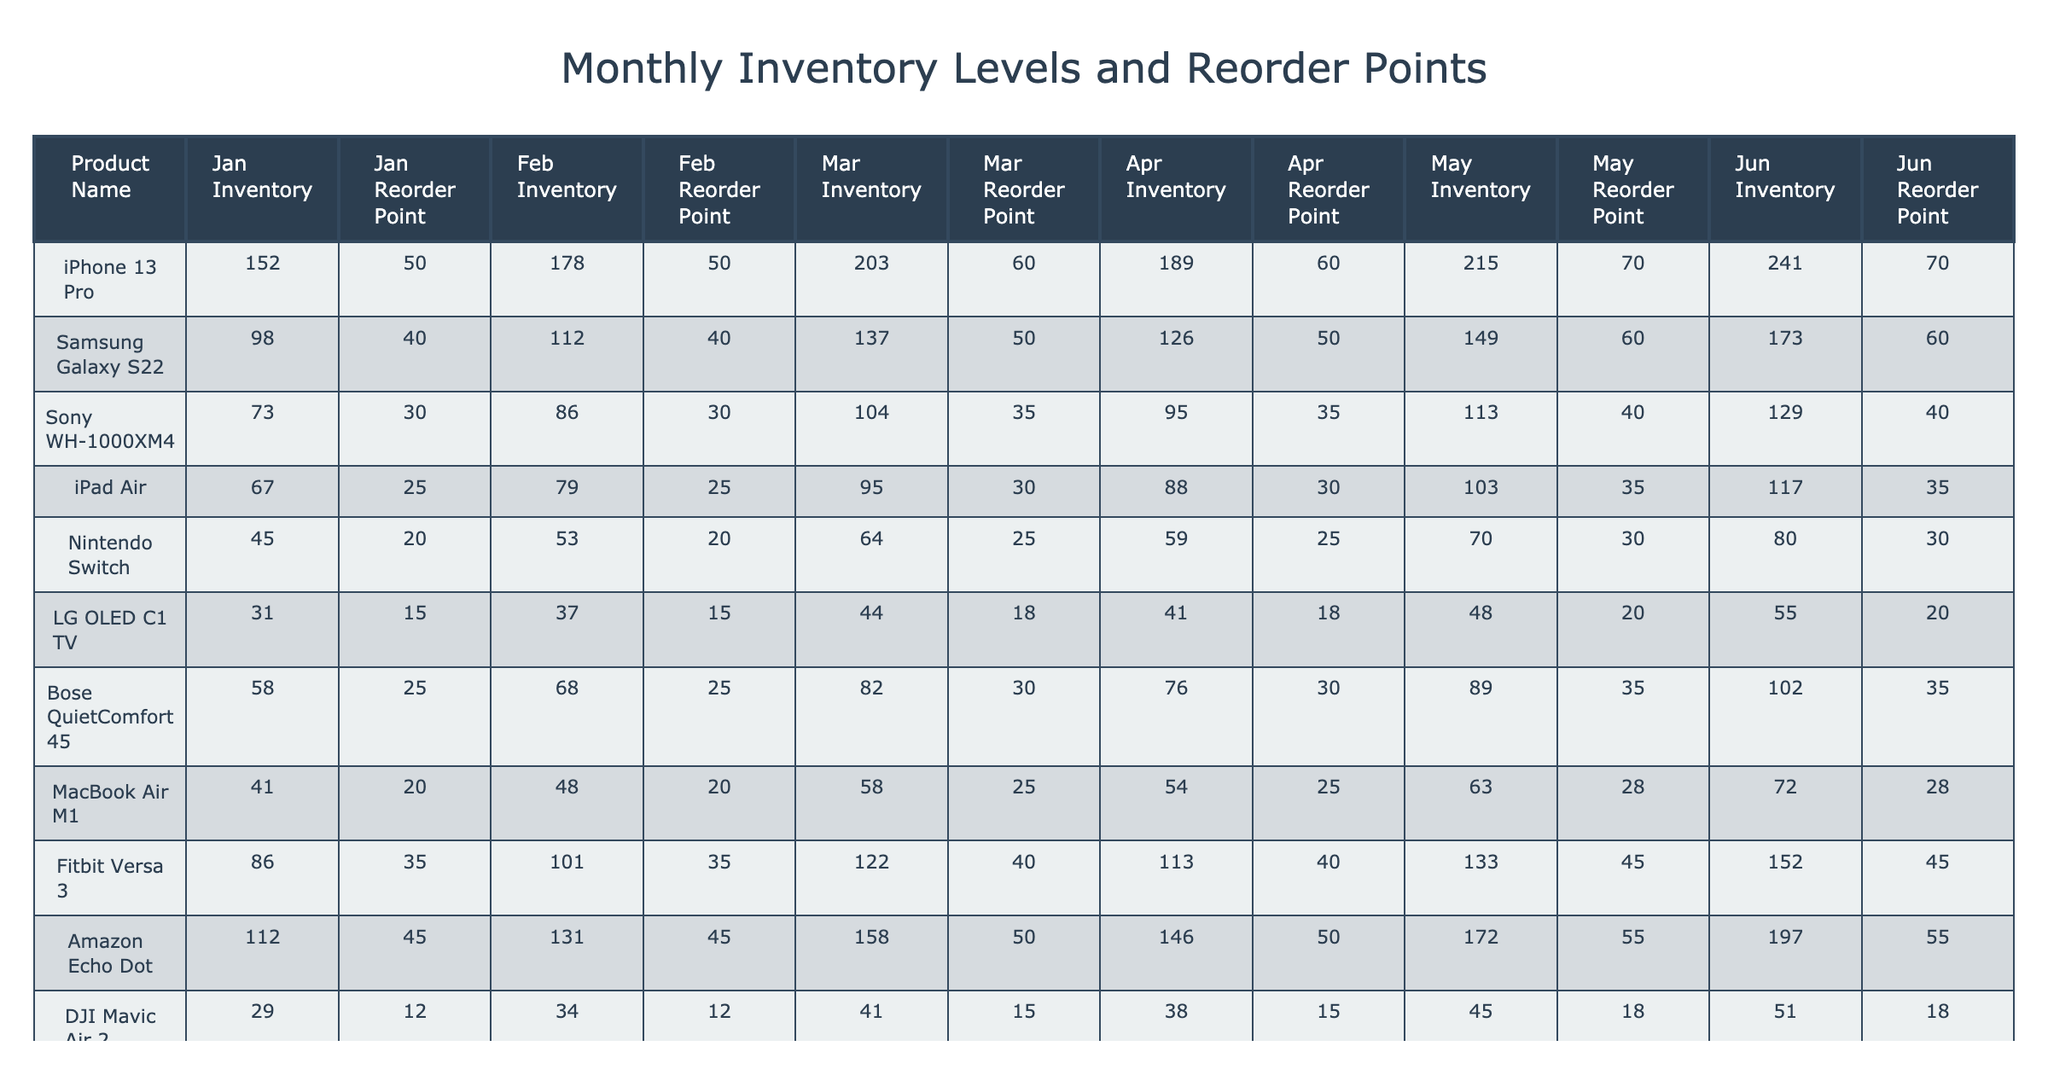What is the inventory level of the Samsung Galaxy S22 in March? In the table, I locate the row for the Samsung Galaxy S22 and find the value under the "Mar Inventory" column, which is 137.
Answer: 137 What is the reorder point for the iPad Air in April? I check the row for iPad Air and look under the "Apr Reorder Point" column, which shows a value of 30.
Answer: 30 How many products have a June inventory greater than 100? I examine the June Inventory column and count the products with values higher than 100: iPhone 13 Pro (241), Samsung Galaxy S22 (173), Bose QuietComfort 45 (102), Fitbit Versa 3 (152), Amazon Echo Dot (197). This gives a total of 5 products.
Answer: 5 What is the average inventory for the Nintendo Switch over the first five months? I sum the inventory levels from January to May (45 + 53 + 64 + 59 + 70 = 291) and then divide by the number of months, which is 5: 291/5 = 58.2.
Answer: 58.2 Is the reorder point for the Logitech MX Master 3 in January greater than or equal to 25? I check the January reorder point for Logitech MX Master 3, which is 25, and since 25 is equal to 25, the answer is true.
Answer: Yes What is the difference in inventory levels between May and February for the iPhone 13 Pro? For the iPhone 13 Pro, I find the May Inventory (215) and February Inventory (178) and calculate the difference: 215 - 178 = 37.
Answer: 37 Which product has the highest inventory in April? I look through the April Inventory column and find the maximum value, which is 215 for the iPhone 13 Pro.
Answer: iPhone 13 Pro What is the total inventory of all products in June? First, I sum the inventory levels in June: 241 + 173 + 129 + 117 + 80 + 55 + 102 + 72 + 152 + 51 + 112 = 1,866.
Answer: 1866 Does the Sony WH-1000XM4 have a higher reorder point in March than the iPad Air's reorder point in March? Sony WH-1000XM4's reorder point in March is 35, while iPad Air's is 30. Since 35 is greater than 30, this statement is true.
Answer: Yes What product has the lowest reorder point in May? I check the May Reorder Point column and identify the lowest value, which is 20 for both the LG OLED C1 TV and DJI Mavic Air 2.
Answer: LG OLED C1 TV, DJI Mavic Air 2 